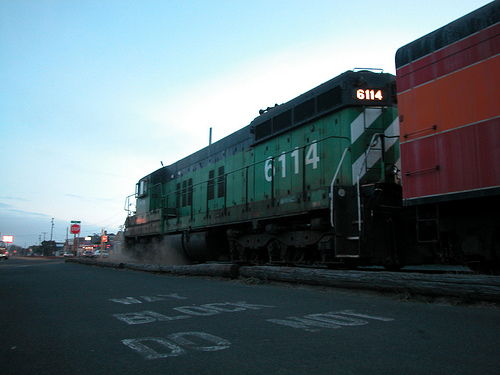If you could hear the train, what sounds would be present in this setting? In this setting with the train in view, you might hear the rhythmic clatter of the metal wheels on the tracks, a distant rumble as the train moves, and possibly the horn of the train blowing intermittently. There might also be subtle ambient noises such as the hum of nearby traffic, the whisper of the wind, and perhaps distant city sounds like people talking or doors opening and closing. 